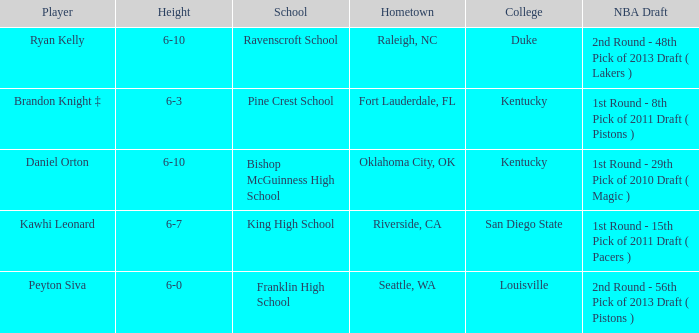Which school is in Riverside, CA? King High School. 